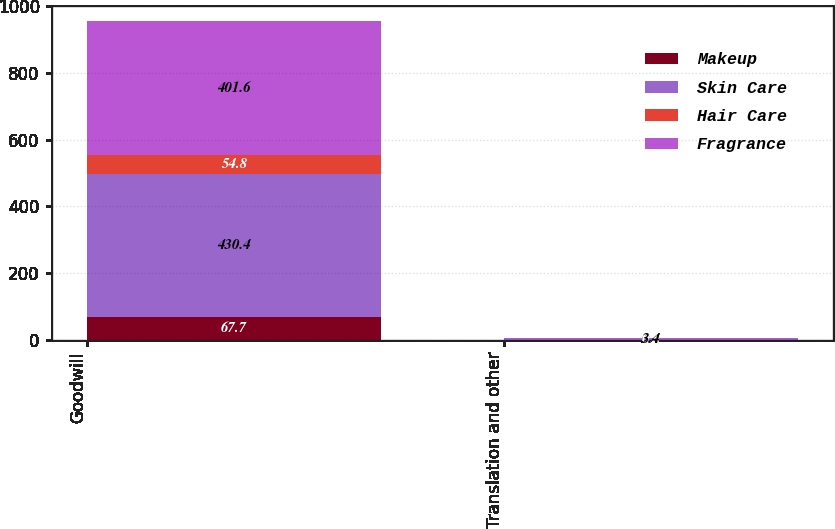Convert chart. <chart><loc_0><loc_0><loc_500><loc_500><stacked_bar_chart><ecel><fcel>Goodwill<fcel>Translation and other<nl><fcel>Makeup<fcel>67.7<fcel>0.6<nl><fcel>Skin Care<fcel>430.4<fcel>0.4<nl><fcel>Hair Care<fcel>54.8<fcel>0.3<nl><fcel>Fragrance<fcel>401.6<fcel>3.4<nl></chart> 